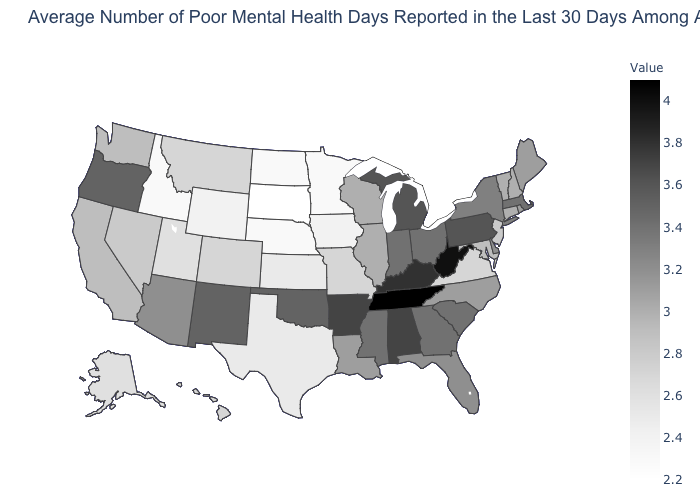Which states have the highest value in the USA?
Quick response, please. Tennessee. Is the legend a continuous bar?
Be succinct. Yes. Does the map have missing data?
Quick response, please. No. Which states have the lowest value in the Northeast?
Keep it brief. New Jersey. Does North Dakota have a higher value than New York?
Keep it brief. No. Is the legend a continuous bar?
Give a very brief answer. Yes. Does Rhode Island have a lower value than Utah?
Write a very short answer. No. 